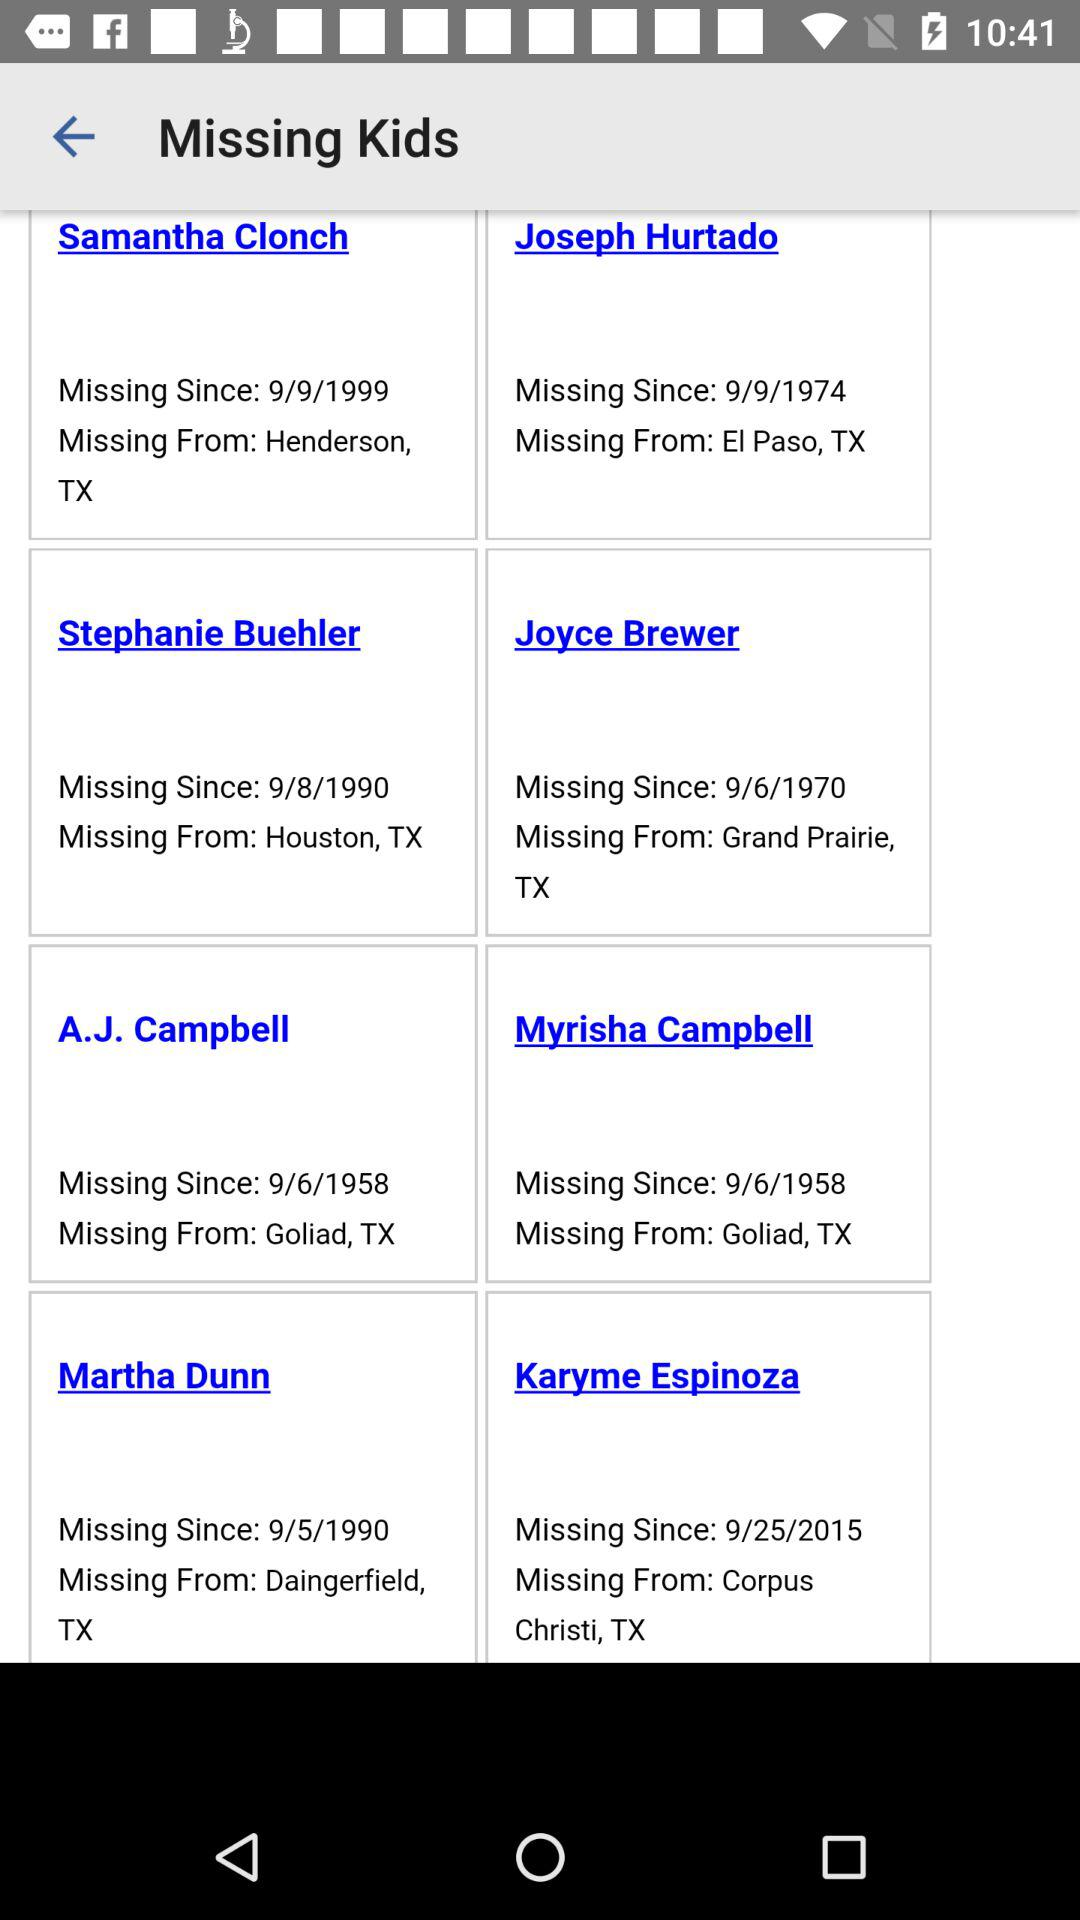What is the missing date of A.J. Campbell? The missing date of A.J. Campbell is 9/6/1958. 